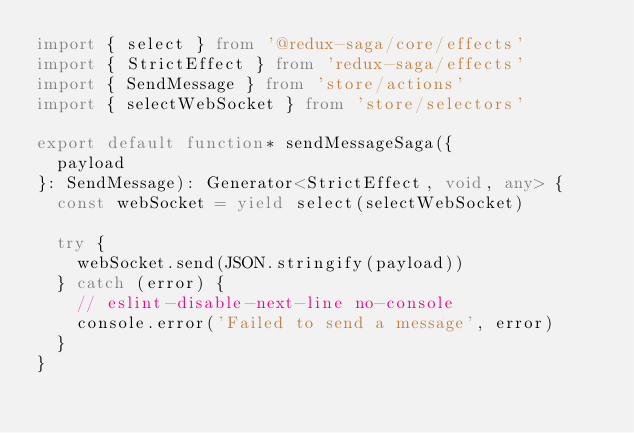<code> <loc_0><loc_0><loc_500><loc_500><_TypeScript_>import { select } from '@redux-saga/core/effects'
import { StrictEffect } from 'redux-saga/effects'
import { SendMessage } from 'store/actions'
import { selectWebSocket } from 'store/selectors'

export default function* sendMessageSaga({
  payload
}: SendMessage): Generator<StrictEffect, void, any> {
  const webSocket = yield select(selectWebSocket)

  try {
    webSocket.send(JSON.stringify(payload))
  } catch (error) {
    // eslint-disable-next-line no-console
    console.error('Failed to send a message', error)
  }
}
</code> 